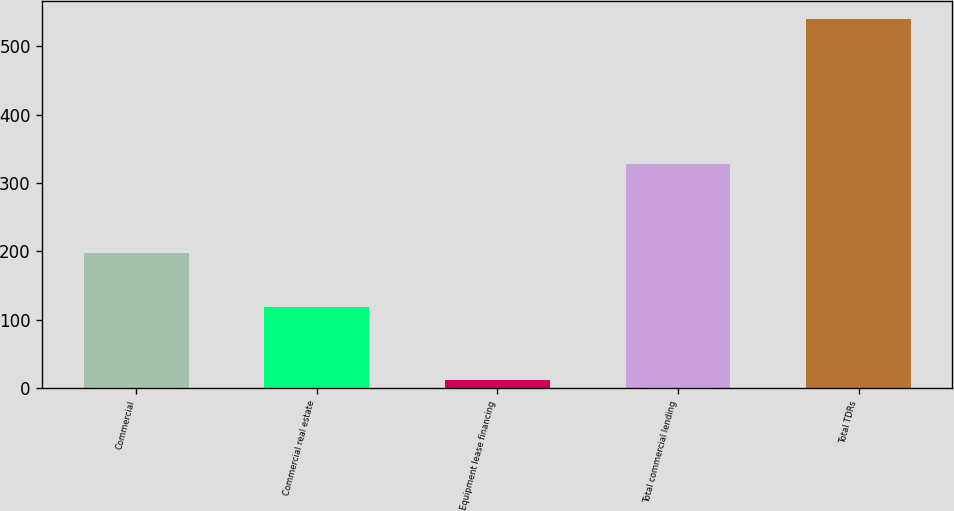Convert chart to OTSL. <chart><loc_0><loc_0><loc_500><loc_500><bar_chart><fcel>Commercial<fcel>Commercial real estate<fcel>Equipment lease financing<fcel>Total commercial lending<fcel>Total TDRs<nl><fcel>198<fcel>118<fcel>12<fcel>328<fcel>540<nl></chart> 